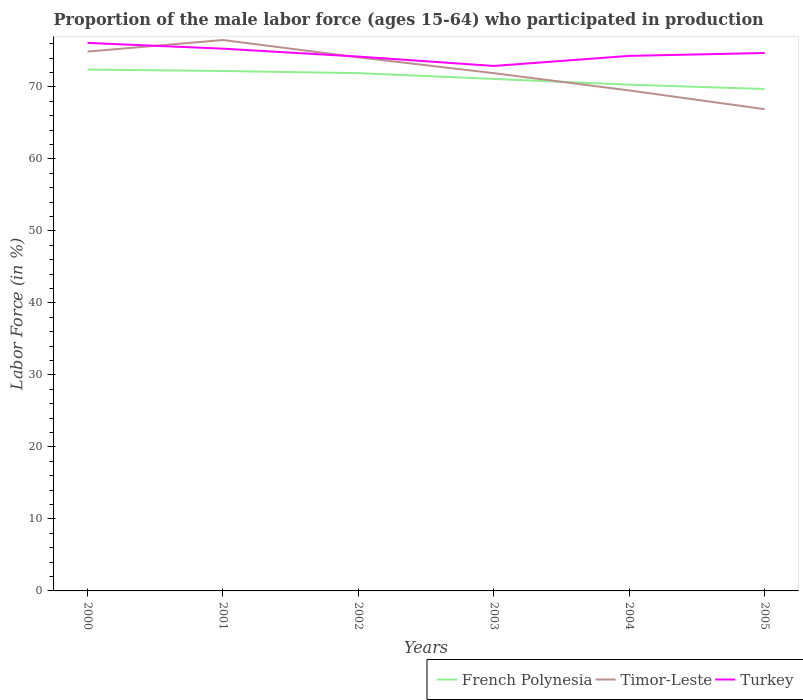Does the line corresponding to Timor-Leste intersect with the line corresponding to French Polynesia?
Provide a short and direct response. Yes. Across all years, what is the maximum proportion of the male labor force who participated in production in Timor-Leste?
Provide a short and direct response. 66.9. In which year was the proportion of the male labor force who participated in production in Timor-Leste maximum?
Offer a very short reply. 2005. What is the total proportion of the male labor force who participated in production in Timor-Leste in the graph?
Your response must be concise. 2.4. What is the difference between the highest and the second highest proportion of the male labor force who participated in production in Turkey?
Provide a short and direct response. 3.2. What is the difference between the highest and the lowest proportion of the male labor force who participated in production in Turkey?
Make the answer very short. 3. Does the graph contain grids?
Make the answer very short. No. How many legend labels are there?
Give a very brief answer. 3. How are the legend labels stacked?
Make the answer very short. Horizontal. What is the title of the graph?
Make the answer very short. Proportion of the male labor force (ages 15-64) who participated in production. Does "Middle East & North Africa (all income levels)" appear as one of the legend labels in the graph?
Make the answer very short. No. What is the Labor Force (in %) in French Polynesia in 2000?
Keep it short and to the point. 72.4. What is the Labor Force (in %) of Timor-Leste in 2000?
Provide a short and direct response. 74.9. What is the Labor Force (in %) in Turkey in 2000?
Make the answer very short. 76.1. What is the Labor Force (in %) in French Polynesia in 2001?
Your answer should be very brief. 72.2. What is the Labor Force (in %) of Timor-Leste in 2001?
Your answer should be compact. 76.5. What is the Labor Force (in %) in Turkey in 2001?
Your answer should be compact. 75.3. What is the Labor Force (in %) of French Polynesia in 2002?
Offer a very short reply. 71.9. What is the Labor Force (in %) in Timor-Leste in 2002?
Keep it short and to the point. 74.1. What is the Labor Force (in %) of Turkey in 2002?
Give a very brief answer. 74.2. What is the Labor Force (in %) in French Polynesia in 2003?
Give a very brief answer. 71.1. What is the Labor Force (in %) of Timor-Leste in 2003?
Keep it short and to the point. 71.9. What is the Labor Force (in %) in Turkey in 2003?
Offer a very short reply. 72.9. What is the Labor Force (in %) of French Polynesia in 2004?
Ensure brevity in your answer.  70.3. What is the Labor Force (in %) in Timor-Leste in 2004?
Offer a very short reply. 69.5. What is the Labor Force (in %) of Turkey in 2004?
Keep it short and to the point. 74.3. What is the Labor Force (in %) of French Polynesia in 2005?
Provide a short and direct response. 69.7. What is the Labor Force (in %) in Timor-Leste in 2005?
Your answer should be very brief. 66.9. What is the Labor Force (in %) of Turkey in 2005?
Make the answer very short. 74.7. Across all years, what is the maximum Labor Force (in %) of French Polynesia?
Give a very brief answer. 72.4. Across all years, what is the maximum Labor Force (in %) in Timor-Leste?
Keep it short and to the point. 76.5. Across all years, what is the maximum Labor Force (in %) in Turkey?
Your answer should be very brief. 76.1. Across all years, what is the minimum Labor Force (in %) in French Polynesia?
Your answer should be compact. 69.7. Across all years, what is the minimum Labor Force (in %) in Timor-Leste?
Your response must be concise. 66.9. Across all years, what is the minimum Labor Force (in %) of Turkey?
Give a very brief answer. 72.9. What is the total Labor Force (in %) of French Polynesia in the graph?
Your response must be concise. 427.6. What is the total Labor Force (in %) in Timor-Leste in the graph?
Keep it short and to the point. 433.8. What is the total Labor Force (in %) in Turkey in the graph?
Provide a succinct answer. 447.5. What is the difference between the Labor Force (in %) in French Polynesia in 2000 and that in 2001?
Your response must be concise. 0.2. What is the difference between the Labor Force (in %) of Timor-Leste in 2000 and that in 2002?
Give a very brief answer. 0.8. What is the difference between the Labor Force (in %) of French Polynesia in 2000 and that in 2003?
Your answer should be very brief. 1.3. What is the difference between the Labor Force (in %) in Turkey in 2000 and that in 2003?
Ensure brevity in your answer.  3.2. What is the difference between the Labor Force (in %) of French Polynesia in 2000 and that in 2004?
Your answer should be very brief. 2.1. What is the difference between the Labor Force (in %) in Timor-Leste in 2000 and that in 2004?
Your answer should be very brief. 5.4. What is the difference between the Labor Force (in %) of Turkey in 2000 and that in 2004?
Offer a very short reply. 1.8. What is the difference between the Labor Force (in %) of French Polynesia in 2000 and that in 2005?
Provide a succinct answer. 2.7. What is the difference between the Labor Force (in %) in Timor-Leste in 2001 and that in 2002?
Ensure brevity in your answer.  2.4. What is the difference between the Labor Force (in %) in French Polynesia in 2001 and that in 2005?
Ensure brevity in your answer.  2.5. What is the difference between the Labor Force (in %) of Timor-Leste in 2001 and that in 2005?
Offer a very short reply. 9.6. What is the difference between the Labor Force (in %) in Turkey in 2001 and that in 2005?
Give a very brief answer. 0.6. What is the difference between the Labor Force (in %) in French Polynesia in 2002 and that in 2003?
Provide a short and direct response. 0.8. What is the difference between the Labor Force (in %) of Timor-Leste in 2002 and that in 2003?
Your response must be concise. 2.2. What is the difference between the Labor Force (in %) in Turkey in 2002 and that in 2003?
Ensure brevity in your answer.  1.3. What is the difference between the Labor Force (in %) of Timor-Leste in 2002 and that in 2004?
Offer a very short reply. 4.6. What is the difference between the Labor Force (in %) of French Polynesia in 2002 and that in 2005?
Provide a succinct answer. 2.2. What is the difference between the Labor Force (in %) in French Polynesia in 2003 and that in 2004?
Offer a terse response. 0.8. What is the difference between the Labor Force (in %) in Timor-Leste in 2003 and that in 2004?
Ensure brevity in your answer.  2.4. What is the difference between the Labor Force (in %) of French Polynesia in 2003 and that in 2005?
Offer a terse response. 1.4. What is the difference between the Labor Force (in %) in French Polynesia in 2004 and that in 2005?
Provide a succinct answer. 0.6. What is the difference between the Labor Force (in %) of Timor-Leste in 2004 and that in 2005?
Provide a succinct answer. 2.6. What is the difference between the Labor Force (in %) in Turkey in 2004 and that in 2005?
Your answer should be very brief. -0.4. What is the difference between the Labor Force (in %) of French Polynesia in 2000 and the Labor Force (in %) of Turkey in 2001?
Offer a very short reply. -2.9. What is the difference between the Labor Force (in %) of Timor-Leste in 2000 and the Labor Force (in %) of Turkey in 2002?
Your answer should be compact. 0.7. What is the difference between the Labor Force (in %) in French Polynesia in 2000 and the Labor Force (in %) in Turkey in 2004?
Your answer should be very brief. -1.9. What is the difference between the Labor Force (in %) in French Polynesia in 2000 and the Labor Force (in %) in Timor-Leste in 2005?
Provide a succinct answer. 5.5. What is the difference between the Labor Force (in %) of Timor-Leste in 2001 and the Labor Force (in %) of Turkey in 2002?
Make the answer very short. 2.3. What is the difference between the Labor Force (in %) in French Polynesia in 2001 and the Labor Force (in %) in Timor-Leste in 2003?
Provide a succinct answer. 0.3. What is the difference between the Labor Force (in %) in Timor-Leste in 2002 and the Labor Force (in %) in Turkey in 2003?
Give a very brief answer. 1.2. What is the difference between the Labor Force (in %) in French Polynesia in 2002 and the Labor Force (in %) in Timor-Leste in 2005?
Your answer should be compact. 5. What is the difference between the Labor Force (in %) of French Polynesia in 2002 and the Labor Force (in %) of Turkey in 2005?
Your response must be concise. -2.8. What is the difference between the Labor Force (in %) of French Polynesia in 2003 and the Labor Force (in %) of Timor-Leste in 2005?
Provide a short and direct response. 4.2. What is the difference between the Labor Force (in %) in French Polynesia in 2003 and the Labor Force (in %) in Turkey in 2005?
Keep it short and to the point. -3.6. What is the difference between the Labor Force (in %) in Timor-Leste in 2004 and the Labor Force (in %) in Turkey in 2005?
Give a very brief answer. -5.2. What is the average Labor Force (in %) in French Polynesia per year?
Make the answer very short. 71.27. What is the average Labor Force (in %) of Timor-Leste per year?
Make the answer very short. 72.3. What is the average Labor Force (in %) in Turkey per year?
Give a very brief answer. 74.58. In the year 2000, what is the difference between the Labor Force (in %) of Timor-Leste and Labor Force (in %) of Turkey?
Provide a short and direct response. -1.2. In the year 2001, what is the difference between the Labor Force (in %) in French Polynesia and Labor Force (in %) in Timor-Leste?
Provide a short and direct response. -4.3. In the year 2001, what is the difference between the Labor Force (in %) of Timor-Leste and Labor Force (in %) of Turkey?
Ensure brevity in your answer.  1.2. In the year 2002, what is the difference between the Labor Force (in %) of French Polynesia and Labor Force (in %) of Turkey?
Make the answer very short. -2.3. In the year 2002, what is the difference between the Labor Force (in %) in Timor-Leste and Labor Force (in %) in Turkey?
Your answer should be compact. -0.1. In the year 2003, what is the difference between the Labor Force (in %) of Timor-Leste and Labor Force (in %) of Turkey?
Your answer should be compact. -1. In the year 2004, what is the difference between the Labor Force (in %) of French Polynesia and Labor Force (in %) of Timor-Leste?
Provide a succinct answer. 0.8. In the year 2004, what is the difference between the Labor Force (in %) in French Polynesia and Labor Force (in %) in Turkey?
Give a very brief answer. -4. In the year 2004, what is the difference between the Labor Force (in %) of Timor-Leste and Labor Force (in %) of Turkey?
Keep it short and to the point. -4.8. In the year 2005, what is the difference between the Labor Force (in %) in Timor-Leste and Labor Force (in %) in Turkey?
Offer a terse response. -7.8. What is the ratio of the Labor Force (in %) in French Polynesia in 2000 to that in 2001?
Your answer should be very brief. 1. What is the ratio of the Labor Force (in %) in Timor-Leste in 2000 to that in 2001?
Offer a very short reply. 0.98. What is the ratio of the Labor Force (in %) in Turkey in 2000 to that in 2001?
Provide a short and direct response. 1.01. What is the ratio of the Labor Force (in %) in Timor-Leste in 2000 to that in 2002?
Ensure brevity in your answer.  1.01. What is the ratio of the Labor Force (in %) in Turkey in 2000 to that in 2002?
Your answer should be very brief. 1.03. What is the ratio of the Labor Force (in %) of French Polynesia in 2000 to that in 2003?
Your answer should be very brief. 1.02. What is the ratio of the Labor Force (in %) of Timor-Leste in 2000 to that in 2003?
Provide a succinct answer. 1.04. What is the ratio of the Labor Force (in %) in Turkey in 2000 to that in 2003?
Provide a short and direct response. 1.04. What is the ratio of the Labor Force (in %) in French Polynesia in 2000 to that in 2004?
Offer a very short reply. 1.03. What is the ratio of the Labor Force (in %) of Timor-Leste in 2000 to that in 2004?
Keep it short and to the point. 1.08. What is the ratio of the Labor Force (in %) of Turkey in 2000 to that in 2004?
Offer a very short reply. 1.02. What is the ratio of the Labor Force (in %) of French Polynesia in 2000 to that in 2005?
Your response must be concise. 1.04. What is the ratio of the Labor Force (in %) in Timor-Leste in 2000 to that in 2005?
Offer a terse response. 1.12. What is the ratio of the Labor Force (in %) in Turkey in 2000 to that in 2005?
Offer a very short reply. 1.02. What is the ratio of the Labor Force (in %) of French Polynesia in 2001 to that in 2002?
Offer a very short reply. 1. What is the ratio of the Labor Force (in %) of Timor-Leste in 2001 to that in 2002?
Make the answer very short. 1.03. What is the ratio of the Labor Force (in %) of Turkey in 2001 to that in 2002?
Provide a succinct answer. 1.01. What is the ratio of the Labor Force (in %) in French Polynesia in 2001 to that in 2003?
Your response must be concise. 1.02. What is the ratio of the Labor Force (in %) in Timor-Leste in 2001 to that in 2003?
Make the answer very short. 1.06. What is the ratio of the Labor Force (in %) of Turkey in 2001 to that in 2003?
Ensure brevity in your answer.  1.03. What is the ratio of the Labor Force (in %) of French Polynesia in 2001 to that in 2004?
Your response must be concise. 1.03. What is the ratio of the Labor Force (in %) of Timor-Leste in 2001 to that in 2004?
Make the answer very short. 1.1. What is the ratio of the Labor Force (in %) in Turkey in 2001 to that in 2004?
Give a very brief answer. 1.01. What is the ratio of the Labor Force (in %) of French Polynesia in 2001 to that in 2005?
Your answer should be very brief. 1.04. What is the ratio of the Labor Force (in %) in Timor-Leste in 2001 to that in 2005?
Give a very brief answer. 1.14. What is the ratio of the Labor Force (in %) in French Polynesia in 2002 to that in 2003?
Make the answer very short. 1.01. What is the ratio of the Labor Force (in %) in Timor-Leste in 2002 to that in 2003?
Offer a very short reply. 1.03. What is the ratio of the Labor Force (in %) in Turkey in 2002 to that in 2003?
Make the answer very short. 1.02. What is the ratio of the Labor Force (in %) of French Polynesia in 2002 to that in 2004?
Your answer should be compact. 1.02. What is the ratio of the Labor Force (in %) in Timor-Leste in 2002 to that in 2004?
Offer a very short reply. 1.07. What is the ratio of the Labor Force (in %) of French Polynesia in 2002 to that in 2005?
Make the answer very short. 1.03. What is the ratio of the Labor Force (in %) in Timor-Leste in 2002 to that in 2005?
Give a very brief answer. 1.11. What is the ratio of the Labor Force (in %) of French Polynesia in 2003 to that in 2004?
Provide a short and direct response. 1.01. What is the ratio of the Labor Force (in %) of Timor-Leste in 2003 to that in 2004?
Keep it short and to the point. 1.03. What is the ratio of the Labor Force (in %) of Turkey in 2003 to that in 2004?
Your answer should be compact. 0.98. What is the ratio of the Labor Force (in %) of French Polynesia in 2003 to that in 2005?
Give a very brief answer. 1.02. What is the ratio of the Labor Force (in %) in Timor-Leste in 2003 to that in 2005?
Give a very brief answer. 1.07. What is the ratio of the Labor Force (in %) in Turkey in 2003 to that in 2005?
Give a very brief answer. 0.98. What is the ratio of the Labor Force (in %) of French Polynesia in 2004 to that in 2005?
Your answer should be compact. 1.01. What is the ratio of the Labor Force (in %) of Timor-Leste in 2004 to that in 2005?
Offer a very short reply. 1.04. What is the ratio of the Labor Force (in %) in Turkey in 2004 to that in 2005?
Offer a terse response. 0.99. What is the difference between the highest and the second highest Labor Force (in %) of Turkey?
Offer a very short reply. 0.8. What is the difference between the highest and the lowest Labor Force (in %) in Timor-Leste?
Your answer should be compact. 9.6. 